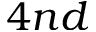<formula> <loc_0><loc_0><loc_500><loc_500>4 n d</formula> 